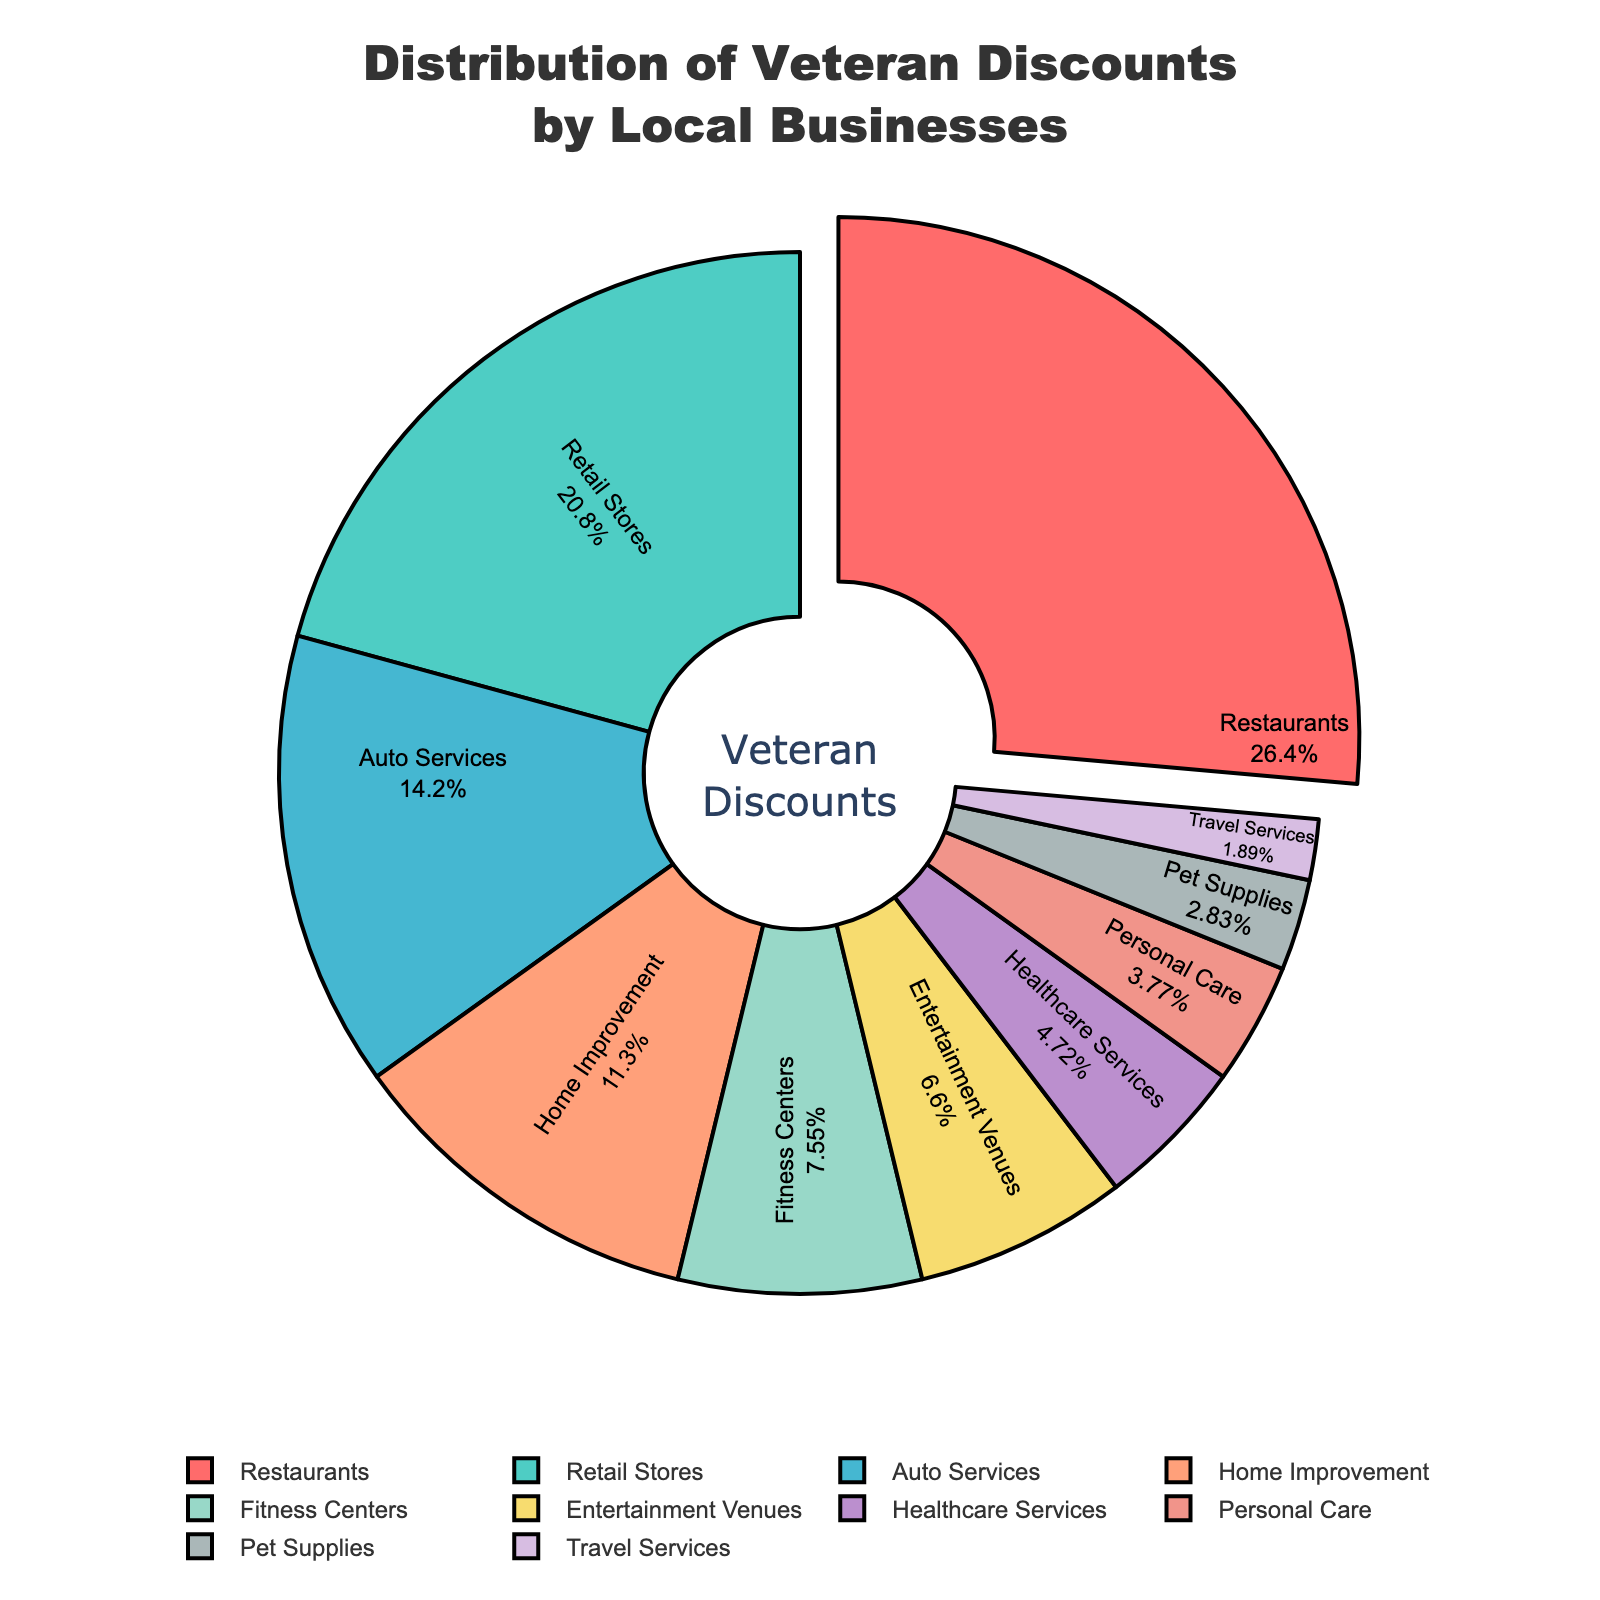what category offers the highest percentage of veteran discounts? The figure shows a pie chart with different segments, each representing a category of veteran discounts. The largest segment is for Restaurants.
Answer: Restaurants How does the percentage of veteran discounts in Retail Stores compare to Home Improvement? From the pie chart, we can compare the sizes of the segments for Retail Stores and Home Improvement. Retail Stores is 22% while Home Improvement is 12%, making Retail Stores much higher.
Answer: Retail Stores is higher What is the combined percentage of veteran discounts offered by Restaurants and Healthcare Services? Adding the percentages for Restaurants (28%) and Healthcare Services (5%): 28 + 5 = 33%
Answer: 33% Which category offers the least percentage of veteran discounts? The smallest segment on the pie chart corresponds to Travel Services, with a percentage of 2%.
Answer: Travel Services How much more significant is the discount percentage for Restaurants compared to Pet Supplies? Restaurants offer 28% while Pet Supplies offer 3%. The difference is 28 - 3 = 25%.
Answer: 25% Are Auto Services offering more veteran discounts than Fitness Centers? According to the pie chart, Auto Services is 15% and Fitness Centers is 8%. Auto Services is offering more.
Answer: Yes What percentage of veteran discounts is provided by Entertainment Venues and Personal Care combined? Adding the percentages for Entertainment Venues (7%) and Personal Care (4%): 7 + 4 = 11%
Answer: 11% Is the percentage of discounts offered by Retail Stores greater than the combined percentage of Personal Care, Pet Supplies, and Travel Services? Retail Stores offer 22%. The combined percentage of Personal Care (4%), Pet Supplies (3%), and Travel Services (2%) is 4 + 3 + 2 = 9%. Therefore, Retail Stores offer a higher percentage.
Answer: Yes Which category, between Home Improvement and Auto Services, offers a lesser percentage of veteran discounts? Comparing Home Improvement (12%) and Auto Services (15%), Home Improvement offers a lesser percentage.
Answer: Home Improvement What's the percentage difference between discounts offered by Restaurants and Entertainment Venues? Subtracting the percentage for Entertainment Venues (7%) from Restaurants (28%): 28 - 7 = 21%
Answer: 21% 